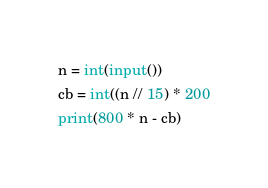Convert code to text. <code><loc_0><loc_0><loc_500><loc_500><_Python_>n = int(input())
cb = int((n // 15) * 200
print(800 * n - cb)
</code> 